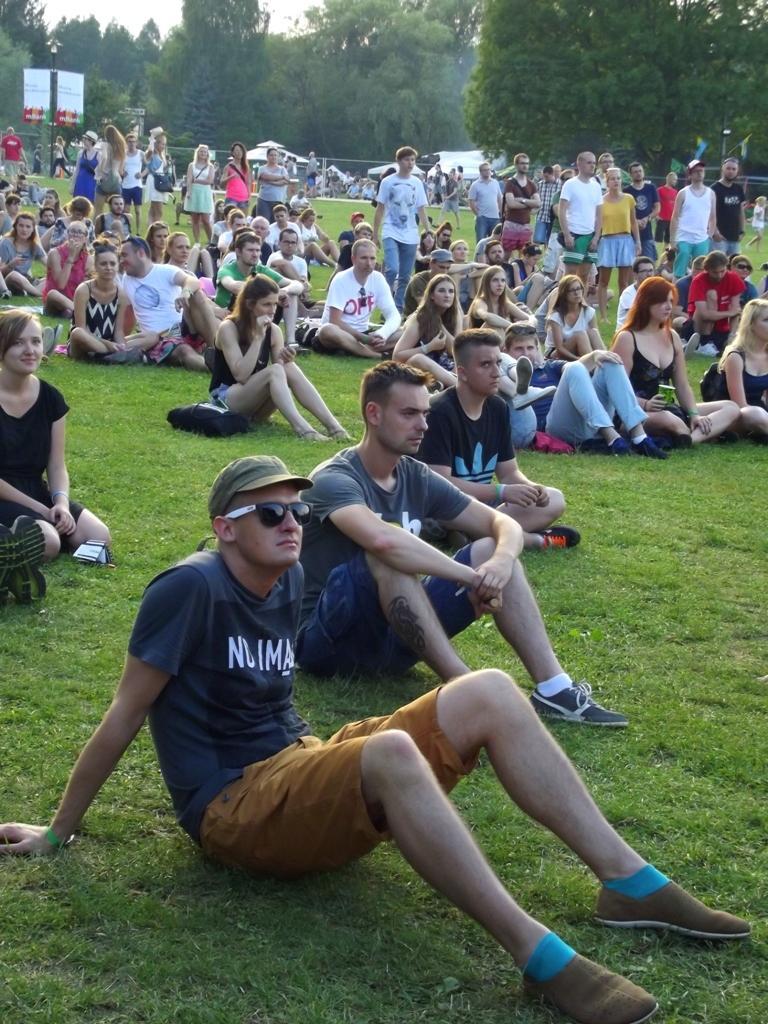In one or two sentences, can you explain what this image depicts? In this image we can see the people sitting on the grass. We can also see a few people standing. In the background we can see the trees, banners and also the sky. 